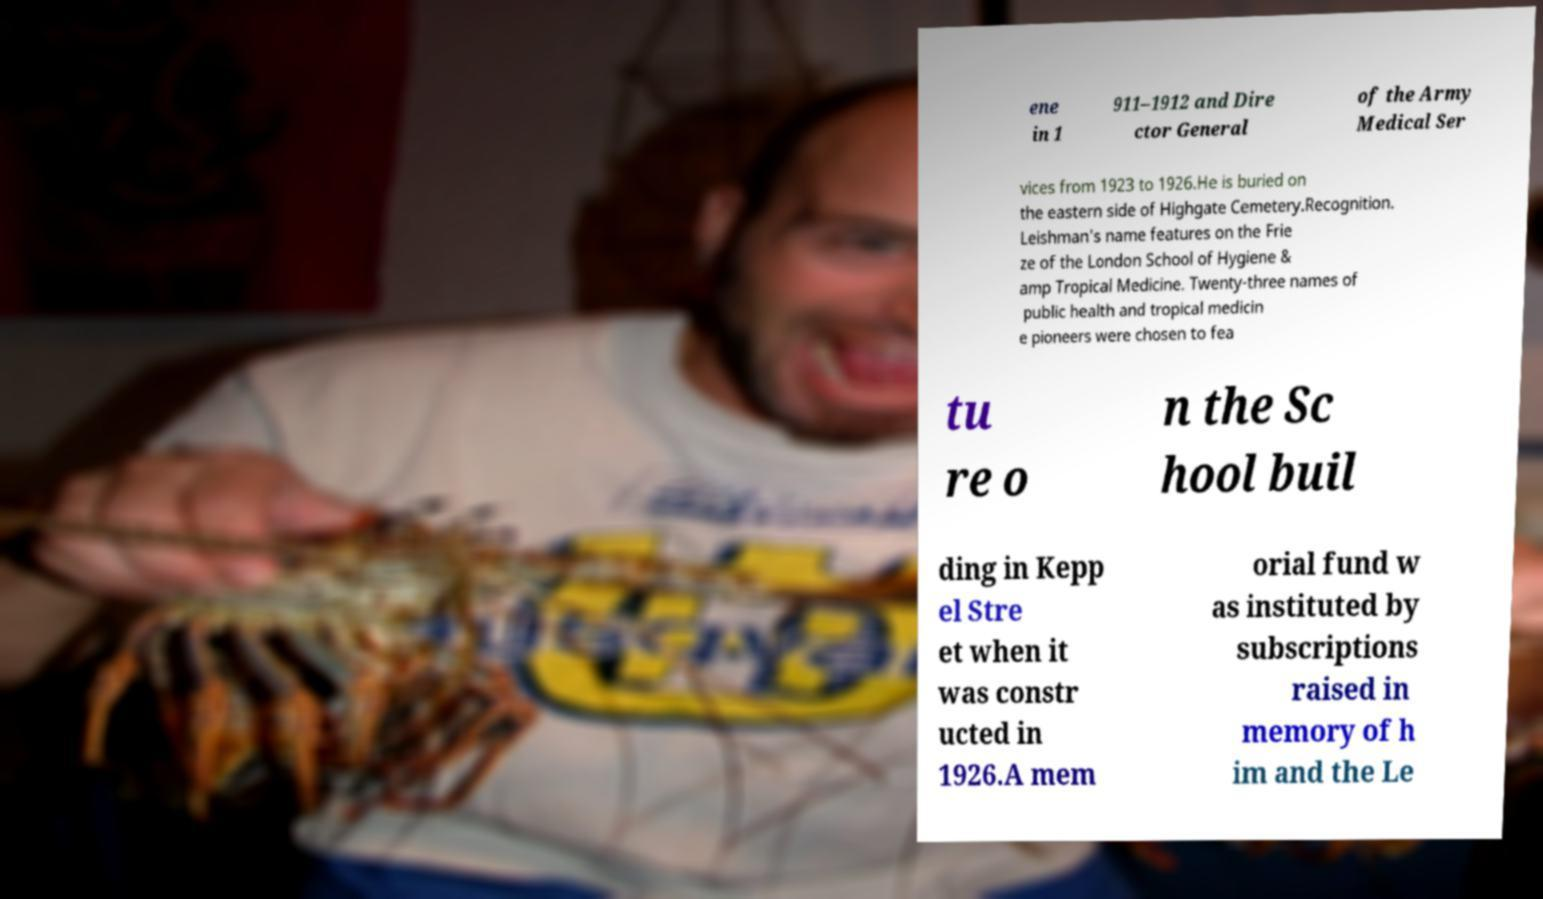What messages or text are displayed in this image? I need them in a readable, typed format. ene in 1 911–1912 and Dire ctor General of the Army Medical Ser vices from 1923 to 1926.He is buried on the eastern side of Highgate Cemetery.Recognition. Leishman's name features on the Frie ze of the London School of Hygiene & amp Tropical Medicine. Twenty-three names of public health and tropical medicin e pioneers were chosen to fea tu re o n the Sc hool buil ding in Kepp el Stre et when it was constr ucted in 1926.A mem orial fund w as instituted by subscriptions raised in memory of h im and the Le 